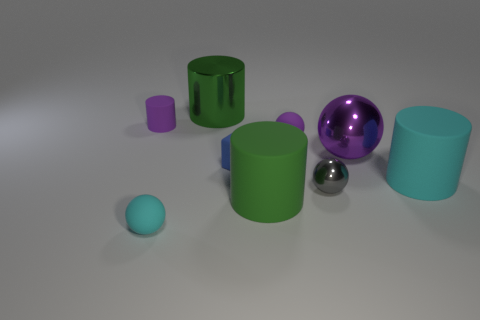Subtract all purple matte balls. How many balls are left? 3 Subtract all gray balls. How many balls are left? 3 Add 3 metallic things. How many metallic things exist? 6 Subtract 1 cyan cylinders. How many objects are left? 8 Subtract all cylinders. How many objects are left? 5 Subtract 4 balls. How many balls are left? 0 Subtract all gray cylinders. Subtract all gray spheres. How many cylinders are left? 4 Subtract all yellow cylinders. How many purple blocks are left? 0 Subtract all tiny gray balls. Subtract all big green rubber cylinders. How many objects are left? 7 Add 3 gray metal balls. How many gray metal balls are left? 4 